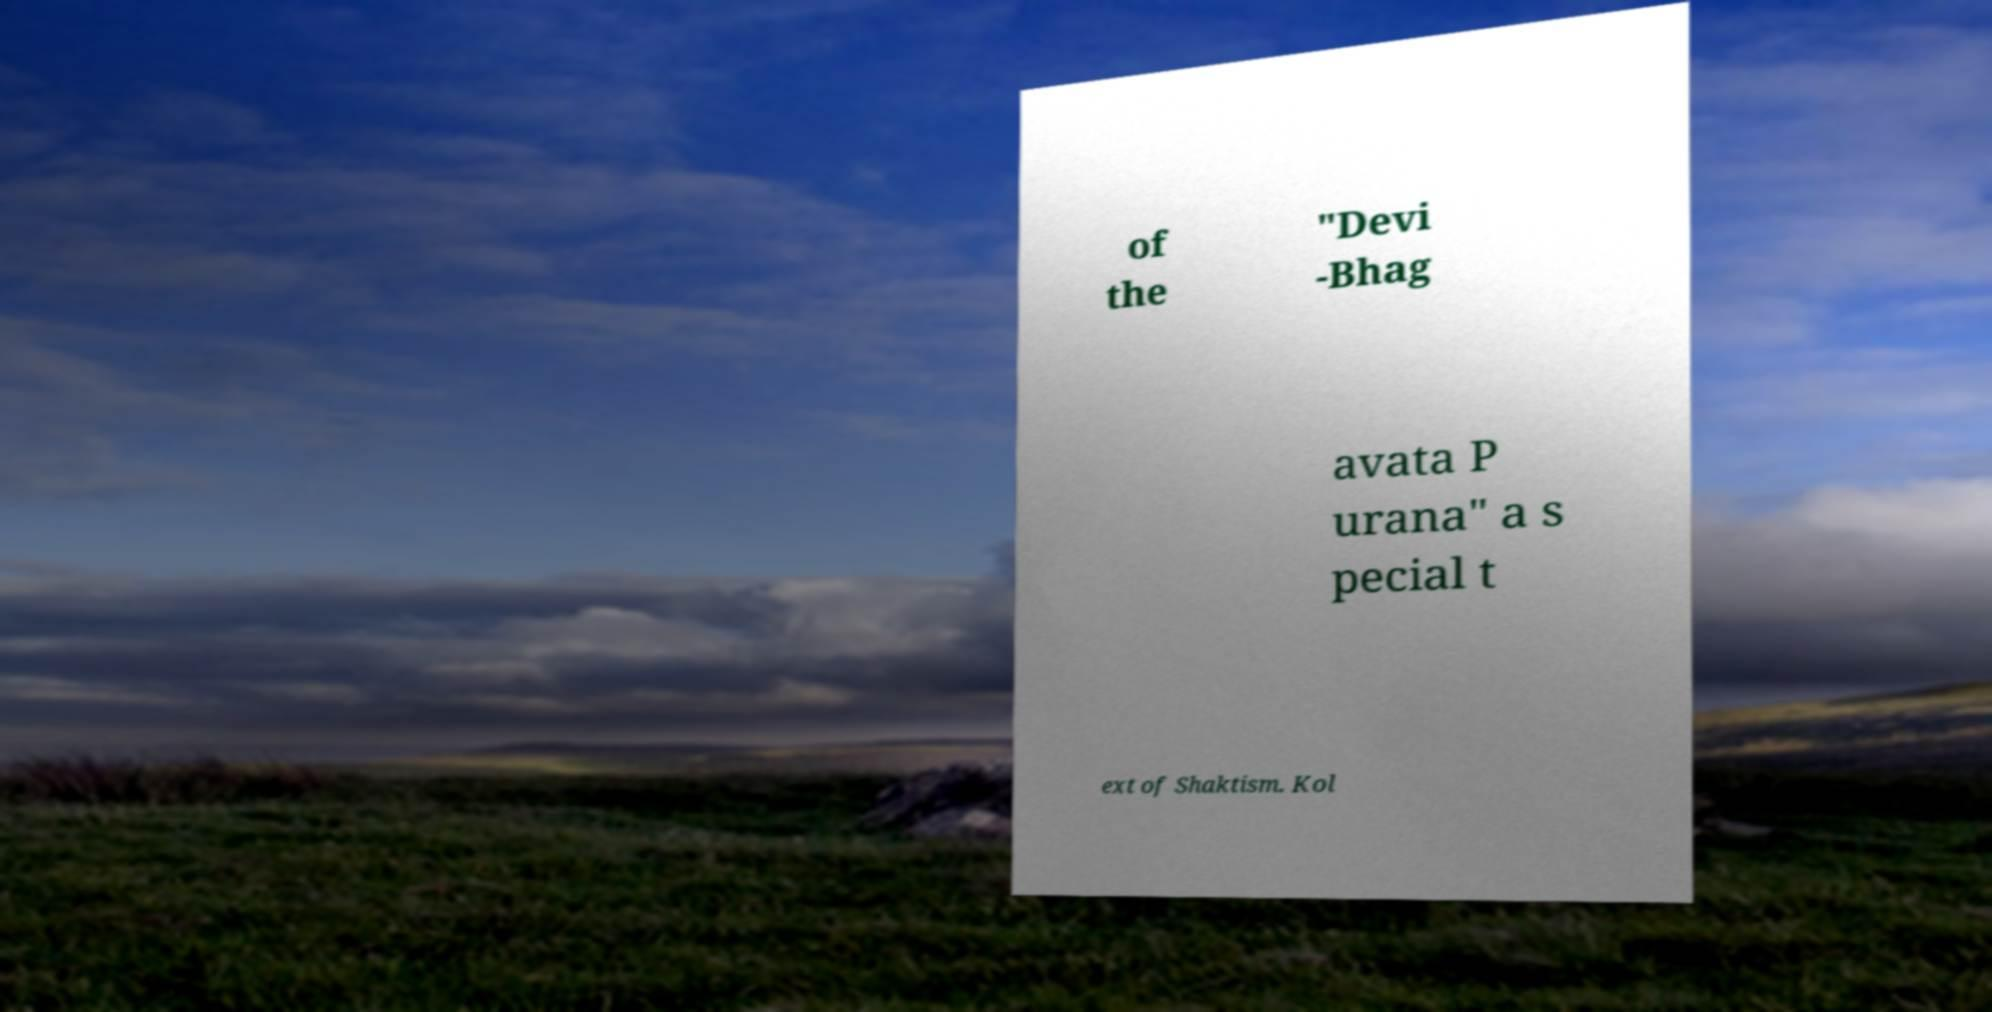Please identify and transcribe the text found in this image. of the "Devi -Bhag avata P urana" a s pecial t ext of Shaktism. Kol 